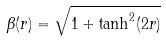Convert formula to latex. <formula><loc_0><loc_0><loc_500><loc_500>\beta ( r ) = \sqrt { 1 + \tanh ^ { 2 } ( 2 r ) }</formula> 